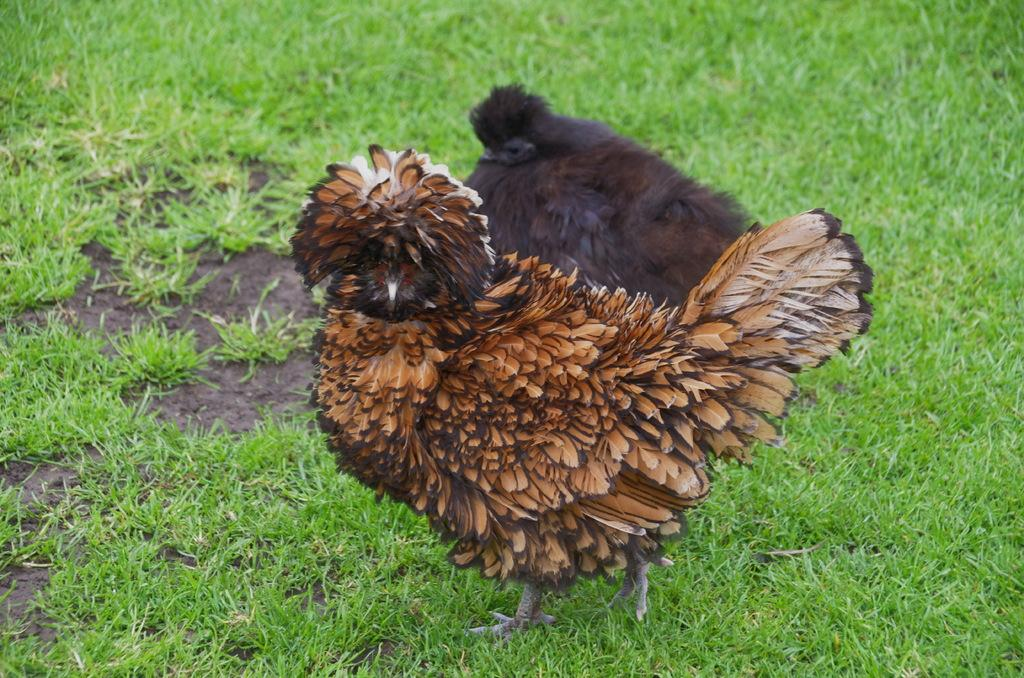How many birds are present in the image? There are two birds in the image. Where are the birds located? The birds are on the ground. What type of vegetation can be seen in the background of the image? There is grass visible in the background of the image. What type of wood is being used to build the shock in the image? There is no shock or wood present in the image; it features two birds on the ground with grass in the background. 